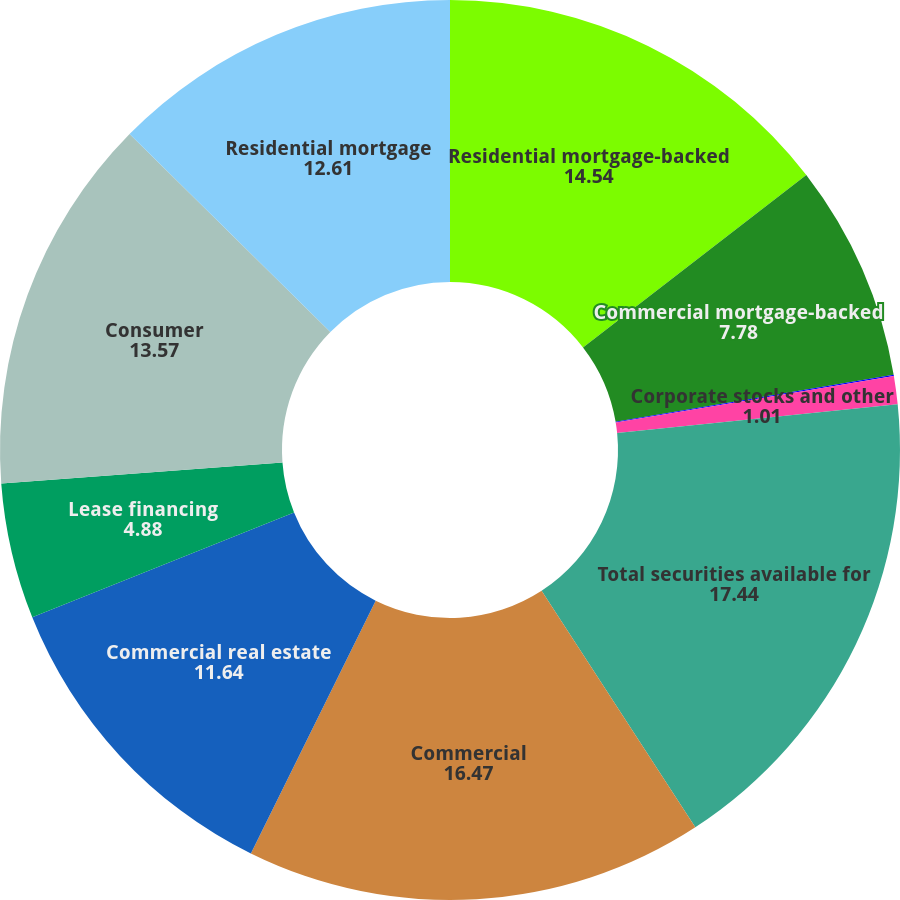<chart> <loc_0><loc_0><loc_500><loc_500><pie_chart><fcel>Residential mortgage-backed<fcel>Commercial mortgage-backed<fcel>US Treasury and government<fcel>Corporate stocks and other<fcel>Total securities available for<fcel>Commercial<fcel>Commercial real estate<fcel>Lease financing<fcel>Consumer<fcel>Residential mortgage<nl><fcel>14.54%<fcel>7.78%<fcel>0.05%<fcel>1.01%<fcel>17.44%<fcel>16.47%<fcel>11.64%<fcel>4.88%<fcel>13.57%<fcel>12.61%<nl></chart> 